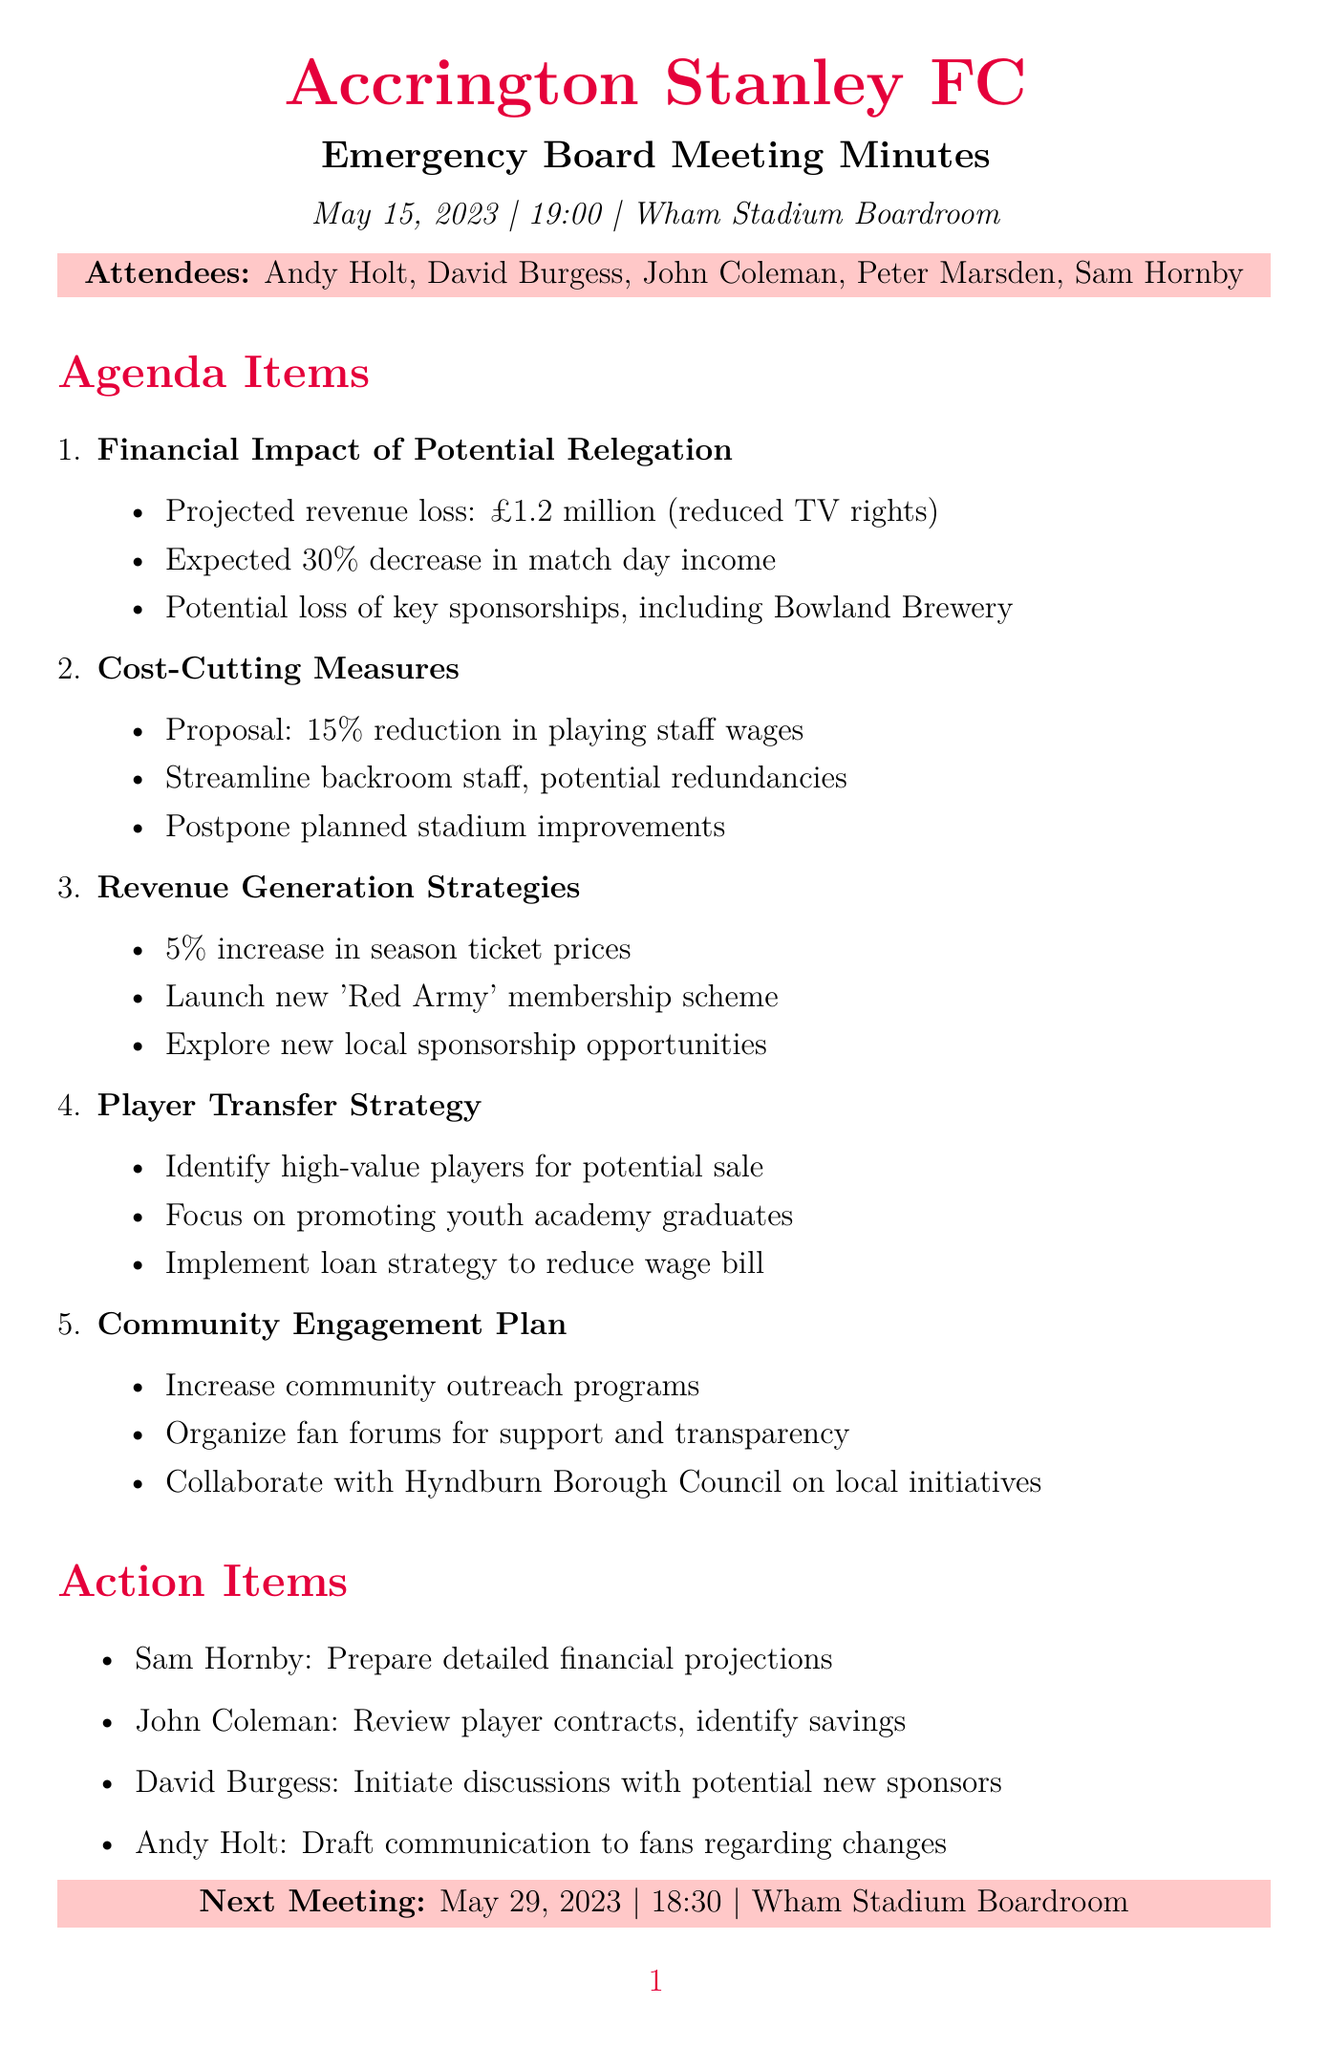What is the date of the meeting? The date of the meeting is explicitly stated in the document as May 15, 2023.
Answer: May 15, 2023 Who is the Chairman of the board? The Chairman is listed among the attendees in the document as Andy Holt.
Answer: Andy Holt What is the projected revenue loss due to reduced TV rights? The document specifies the projected revenue loss due to reduced TV rights as £1.2 million.
Answer: £1.2 million What percentage decrease in match day income is expected? It is noted in the document that an expected 30% decrease in match day income is anticipated.
Answer: 30% What is the proposed reduction in playing staff wages? The proposed reduction in playing staff wages is clearly stated in the document as 15%.
Answer: 15% What is one of the new revenue generation strategies mentioned? The document lists increasing season ticket prices by 5% as one of the revenue generation strategies.
Answer: Increase in season ticket prices by 5% When is the next meeting scheduled? The next meeting date is provided in the document as May 29, 2023.
Answer: May 29, 2023 Who is responsible for preparing detailed financial projections? The action item specifies that Sam Hornby is responsible for preparing detailed financial projections for the next meeting.
Answer: Sam Hornby 